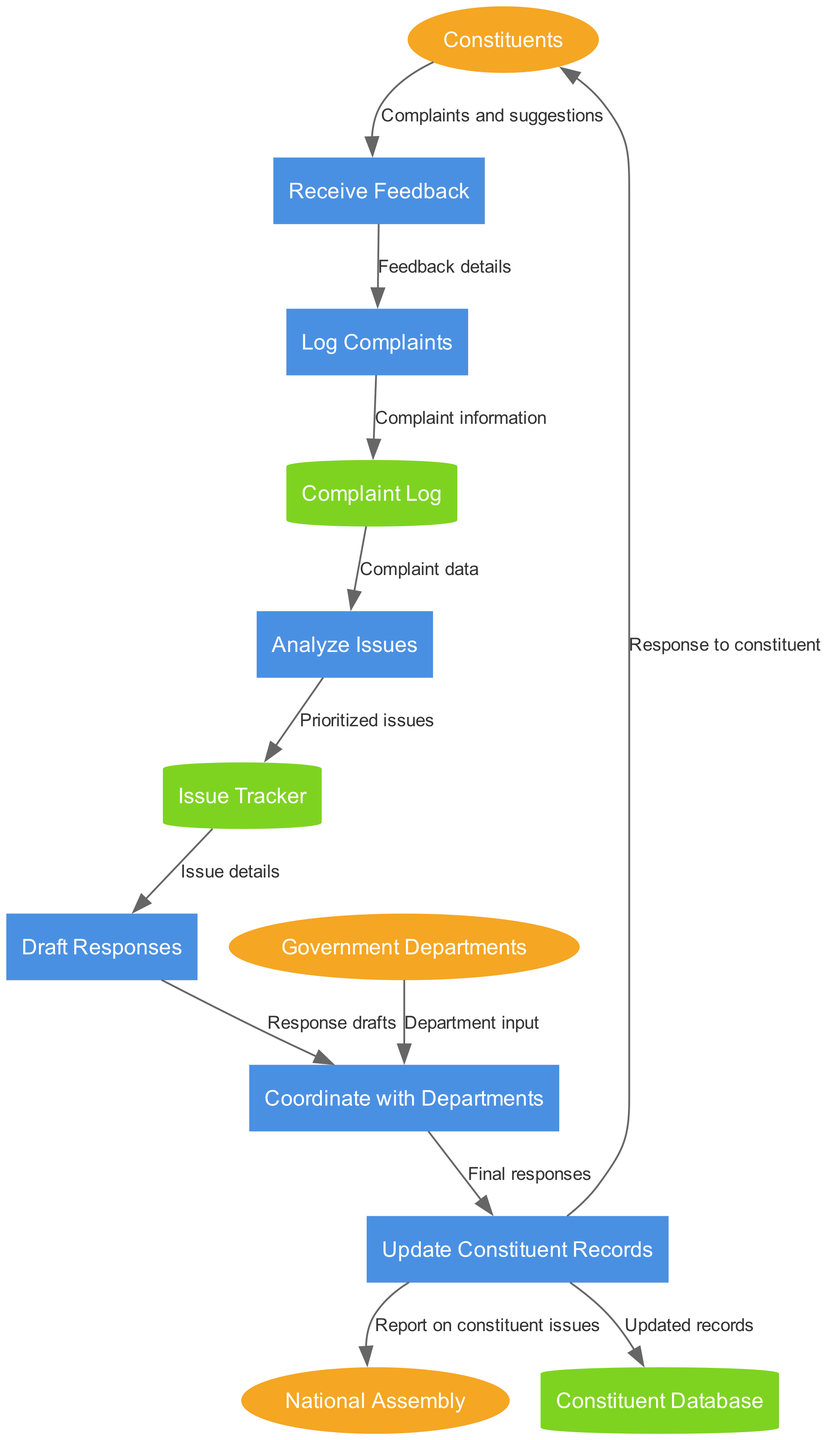What are the external entities in the diagram? The external entities are explicitly listed in the diagram and include "Constituents", "National Assembly", and "Government Departments".
Answer: Constituents, National Assembly, Government Departments How many processes are involved in the feedback handling process? By counting the distinct processes listed in the diagram, we find six: "Receive Feedback", "Log Complaints", "Analyze Issues", "Draft Responses", "Coordinate with Departments", and "Update Constituent Records".
Answer: Six What is the data flow from 'Receive Feedback' to 'Log Complaints'? The flow between these two nodes is labeled "Feedback details", indicating what type of data is transferred. This flow describes the transition from receiving feedback to logging it.
Answer: Feedback details Which process directly receives input from the Government Departments? In the diagram, the process "Coordinate with Departments" receives input from "Government Departments", indicating this is a collaborative process to manage responses.
Answer: Coordinate with Departments What type of data does 'Complaint Log' send to 'Analyze Issues'? The "Complaint Log" sends "Complaint data" to the "Analyze Issues" process, which suggests it is analyzing this specific type of information to identify and prioritize issues.
Answer: Complaint data Which process produces the final outcome that is communicated back to the 'Constituents'? The process "Update Constituent Records" produces the final responses that are communicated back to the "Constituents", indicating it is the concluding step of the feedback handling process before closing the loop with constituents.
Answer: Update Constituent Records How is data from 'Analyze Issues' recorded in the diagram? The process "Analyze Issues" sends "Prioritized issues" to the "Issue Tracker", indicating that issues have been analyzed and prioritized before further action is taken.
Answer: Prioritized issues What happens to the information after it is logged in the 'Complaint Log'? After the information is logged in "Complaint Log", it is sent to "Analyze Issues". This workflow demonstrates that logged complaints are not left idle but continue to another step for action.
Answer: Sent to Analyze Issues How does the process 'Draft Responses' interact with other departments? The "Draft Responses" process coordinates with the "Government Departments", indicating a collaborative effort to draft appropriate responses based on feedback received and issues analyzed.
Answer: Coordinate with Departments 